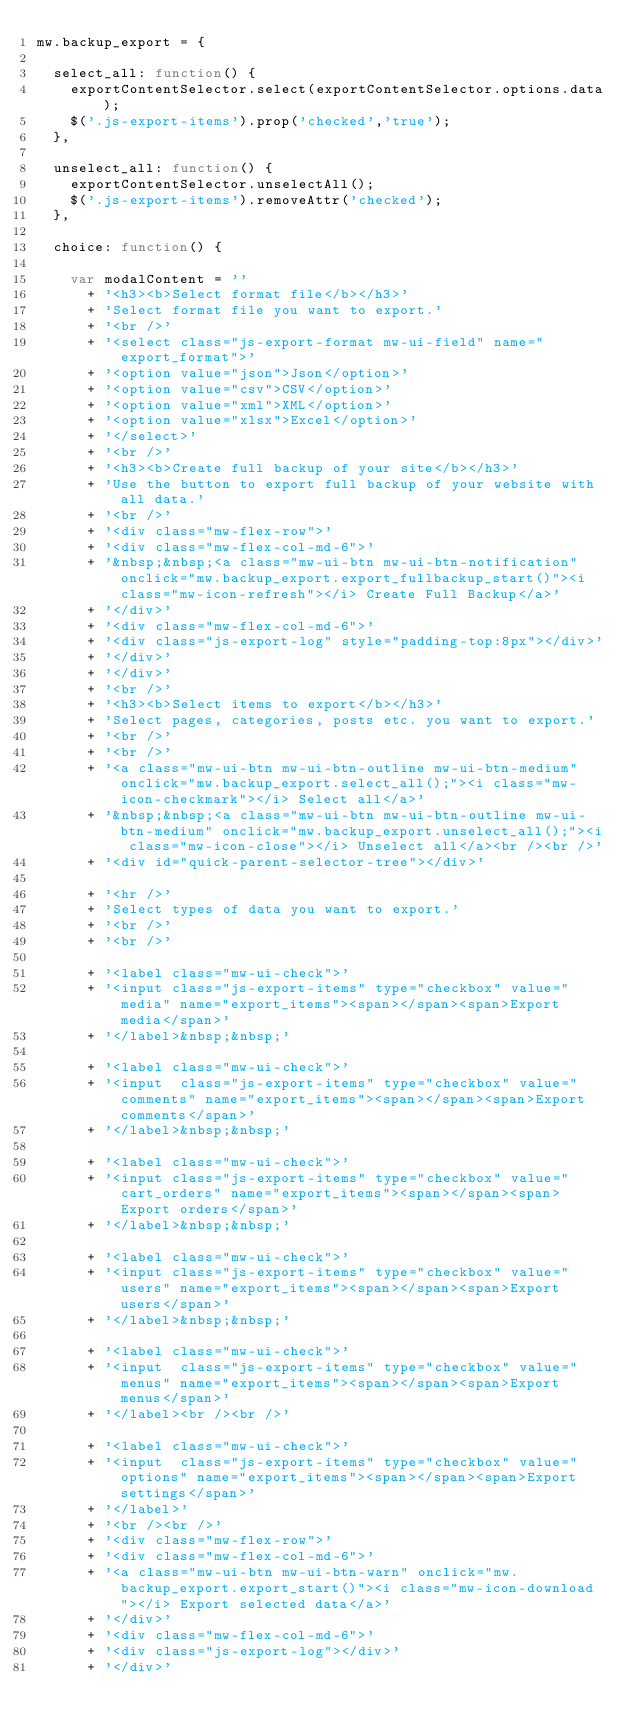<code> <loc_0><loc_0><loc_500><loc_500><_JavaScript_>mw.backup_export = {

	select_all: function() {
		exportContentSelector.select(exportContentSelector.options.data);
		$('.js-export-items').prop('checked','true');
	},
	
	unselect_all: function() {
		exportContentSelector.unselectAll();
		$('.js-export-items').removeAttr('checked');
	},
	
	choice: function() {
		
		var modalContent = ''
			+ '<h3><b>Select format file</b></h3>'
			+ 'Select format file you want to export.'
			+ '<br />'
			+ '<select class="js-export-format mw-ui-field" name="export_format">'
			+ '<option value="json">Json</option>'
			+ '<option value="csv">CSV</option>'
			+ '<option value="xml">XML</option>'
			+ '<option value="xlsx">Excel</option>'
			+ '</select>'
			+ '<br />'
			+ '<h3><b>Create full backup of your site</b></h3>'
			+ 'Use the button to export full backup of your website with all data.'
			+ '<br />'
			+ '<div class="mw-flex-row">'
			+ '<div class="mw-flex-col-md-6">'
			+ '&nbsp;&nbsp;<a class="mw-ui-btn mw-ui-btn-notification" onclick="mw.backup_export.export_fullbackup_start()"><i class="mw-icon-refresh"></i> Create Full Backup</a>'
			+ '</div>'
			+ '<div class="mw-flex-col-md-6">'
			+ '<div class="js-export-log" style="padding-top:8px"></div>'
			+ '</div>'
			+ '</div>'
			+ '<br />'
			+ '<h3><b>Select items to export</b></h3>'
			+ 'Select pages, categories, posts etc. you want to export.'
			+ '<br />'
			+ '<br />'
			+ '<a class="mw-ui-btn mw-ui-btn-outline mw-ui-btn-medium" onclick="mw.backup_export.select_all();"><i class="mw-icon-checkmark"></i> Select all</a>'
			+ '&nbsp;&nbsp;<a class="mw-ui-btn mw-ui-btn-outline mw-ui-btn-medium" onclick="mw.backup_export.unselect_all();"><i class="mw-icon-close"></i> Unselect all</a><br /><br />'
			+ '<div id="quick-parent-selector-tree"></div>'
			
			+ '<hr />'
			+ 'Select types of data you want to export.'
			+ '<br />'
			+ '<br />'
			
			+ '<label class="mw-ui-check">'
			+ '<input class="js-export-items" type="checkbox" value="media" name="export_items"><span></span><span>Export media</span>'
			+ '</label>&nbsp;&nbsp;'
			
			+ '<label class="mw-ui-check">'
			+ '<input  class="js-export-items" type="checkbox" value="comments" name="export_items"><span></span><span>Export comments</span>'
			+ '</label>&nbsp;&nbsp;'
			
			+ '<label class="mw-ui-check">'
			+ '<input class="js-export-items" type="checkbox" value="cart_orders" name="export_items"><span></span><span>Export orders</span>'
			+ '</label>&nbsp;&nbsp;'
			
			+ '<label class="mw-ui-check">'
			+ '<input class="js-export-items" type="checkbox" value="users" name="export_items"><span></span><span>Export users</span>'
			+ '</label>&nbsp;&nbsp;'
			
			+ '<label class="mw-ui-check">'
			+ '<input  class="js-export-items" type="checkbox" value="menus" name="export_items"><span></span><span>Export menus</span>'
			+ '</label><br /><br />'
			
			+ '<label class="mw-ui-check">'
			+ '<input  class="js-export-items" type="checkbox" value="options" name="export_items"><span></span><span>Export settings</span>'
			+ '</label>'
			+ '<br /><br />'
			+ '<div class="mw-flex-row">'
			+ '<div class="mw-flex-col-md-6">'
			+ '<a class="mw-ui-btn mw-ui-btn-warn" onclick="mw.backup_export.export_start()"><i class="mw-icon-download"></i> Export selected data</a>'
			+ '</div>'
			+ '<div class="mw-flex-col-md-6">'
			+ '<div class="js-export-log"></div>'
			+ '</div>'</code> 